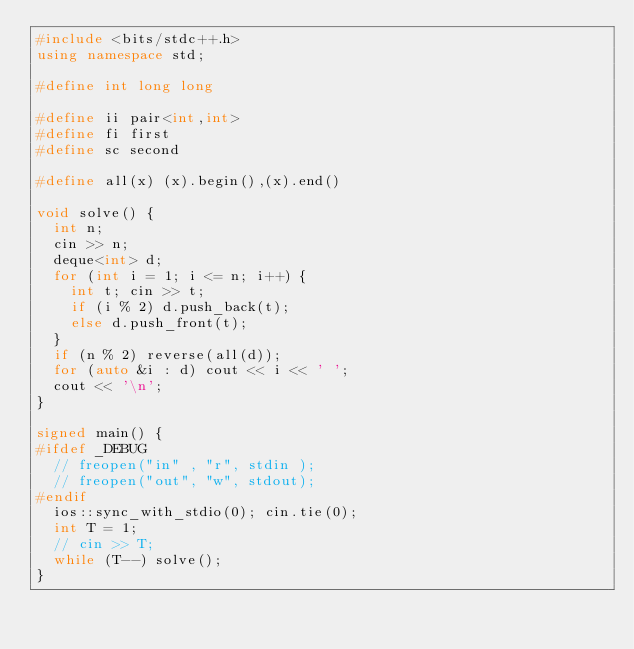<code> <loc_0><loc_0><loc_500><loc_500><_C++_>#include <bits/stdc++.h>
using namespace std;

#define int long long

#define ii pair<int,int>
#define fi first
#define sc second

#define all(x) (x).begin(),(x).end()

void solve() {
  int n;
  cin >> n;
  deque<int> d;
  for (int i = 1; i <= n; i++) {
    int t; cin >> t;
    if (i % 2) d.push_back(t);
    else d.push_front(t);
  }
  if (n % 2) reverse(all(d));
  for (auto &i : d) cout << i << ' ';
  cout << '\n';
}

signed main() {
#ifdef _DEBUG
  // freopen("in" , "r", stdin );
  // freopen("out", "w", stdout);
#endif
  ios::sync_with_stdio(0); cin.tie(0);
  int T = 1;
  // cin >> T;
  while (T--) solve();
}
</code> 